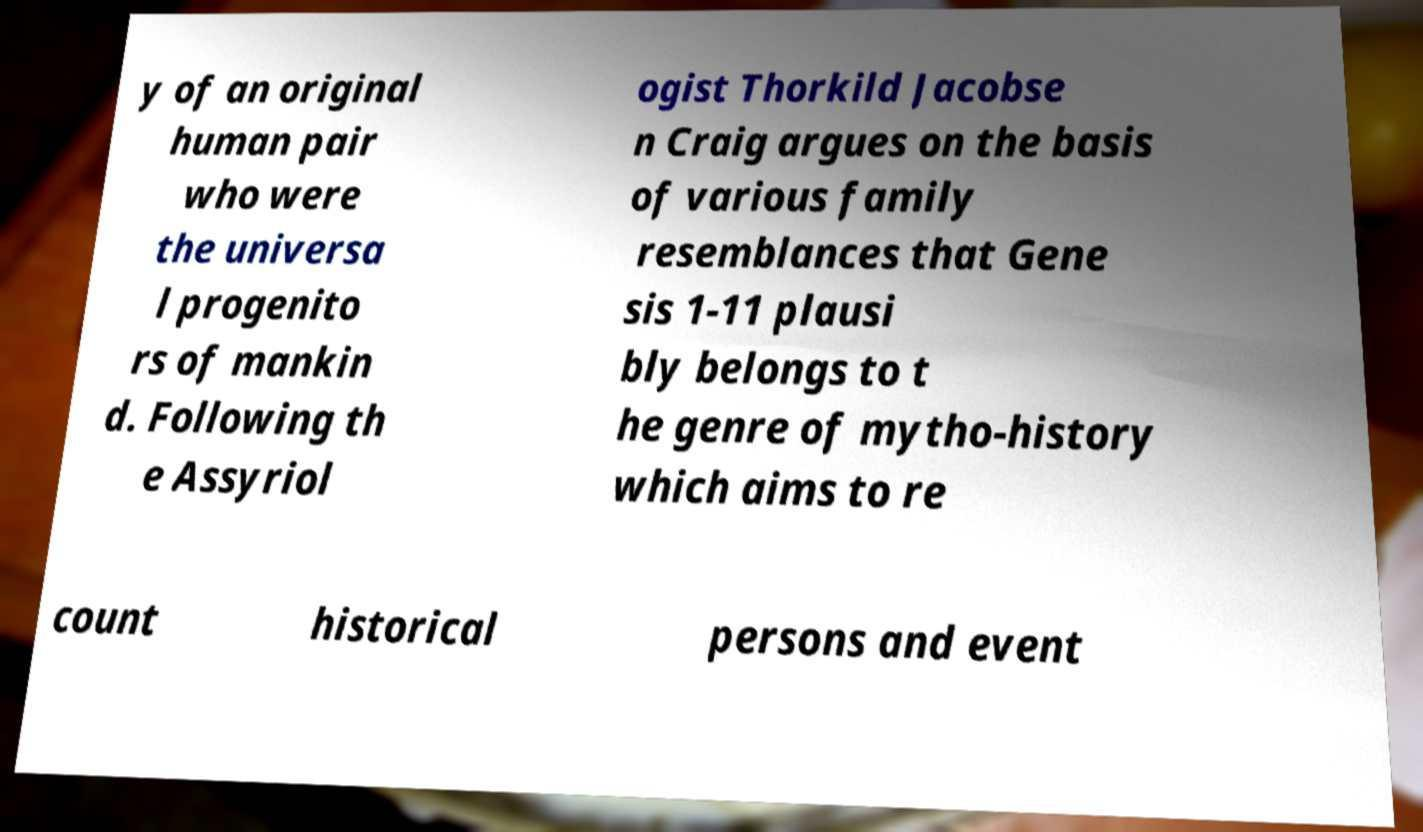There's text embedded in this image that I need extracted. Can you transcribe it verbatim? y of an original human pair who were the universa l progenito rs of mankin d. Following th e Assyriol ogist Thorkild Jacobse n Craig argues on the basis of various family resemblances that Gene sis 1-11 plausi bly belongs to t he genre of mytho-history which aims to re count historical persons and event 